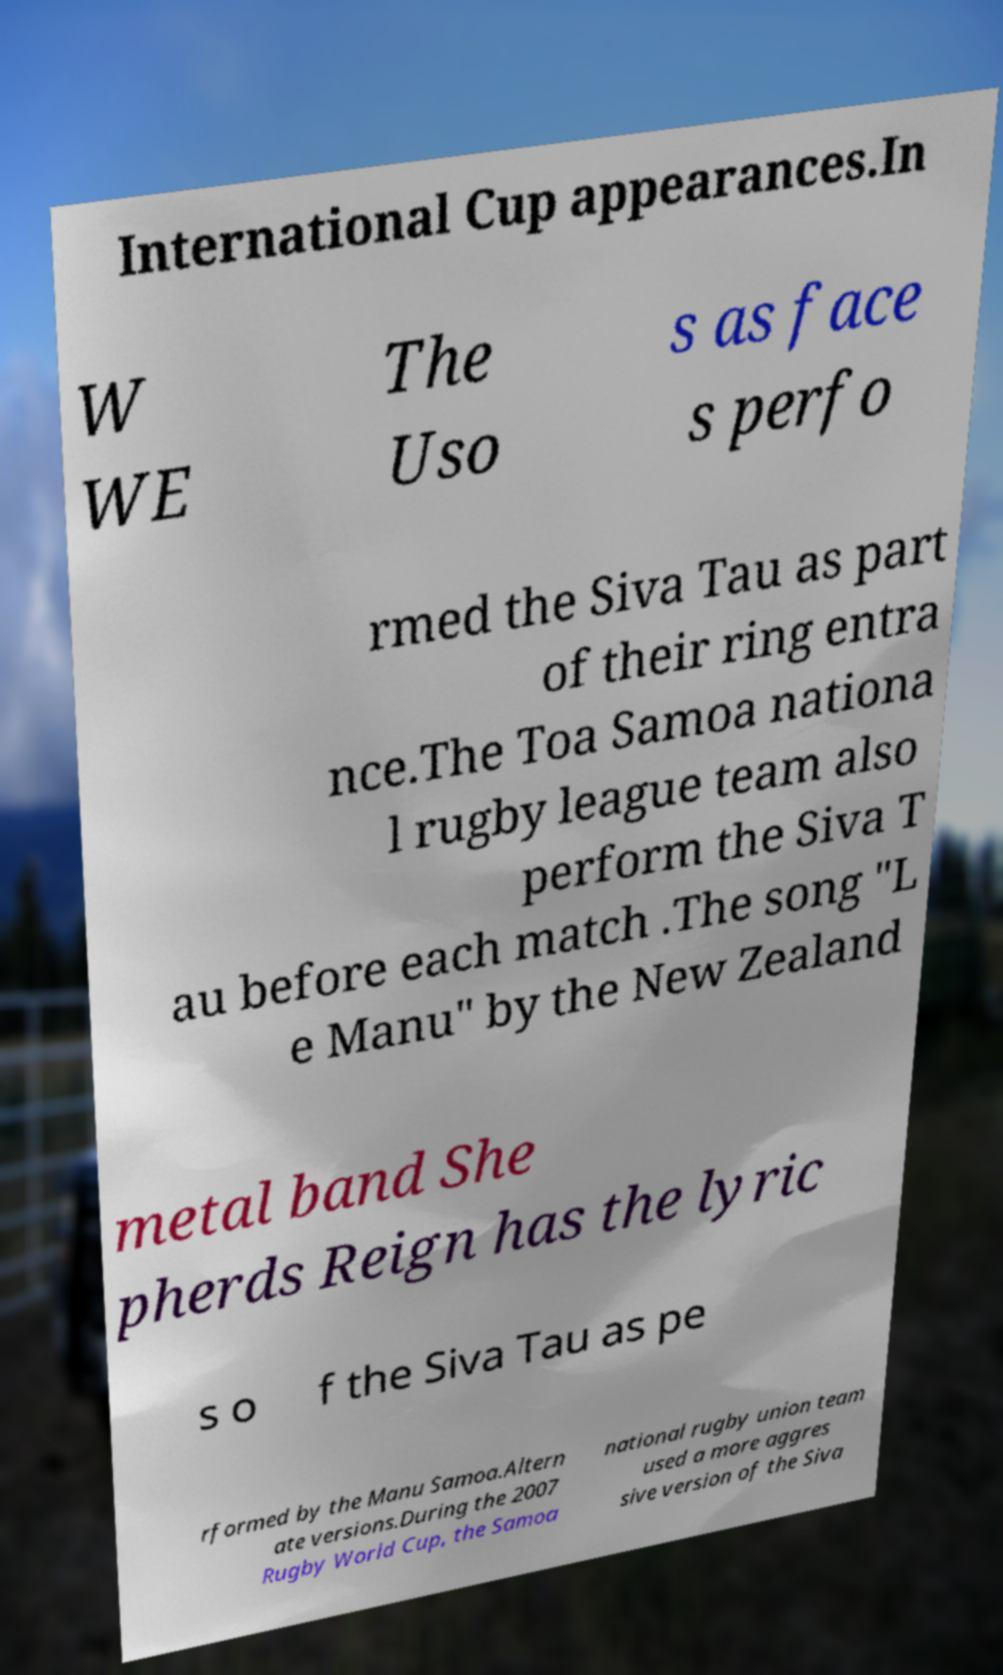For documentation purposes, I need the text within this image transcribed. Could you provide that? International Cup appearances.In W WE The Uso s as face s perfo rmed the Siva Tau as part of their ring entra nce.The Toa Samoa nationa l rugby league team also perform the Siva T au before each match .The song "L e Manu" by the New Zealand metal band She pherds Reign has the lyric s o f the Siva Tau as pe rformed by the Manu Samoa.Altern ate versions.During the 2007 Rugby World Cup, the Samoa national rugby union team used a more aggres sive version of the Siva 